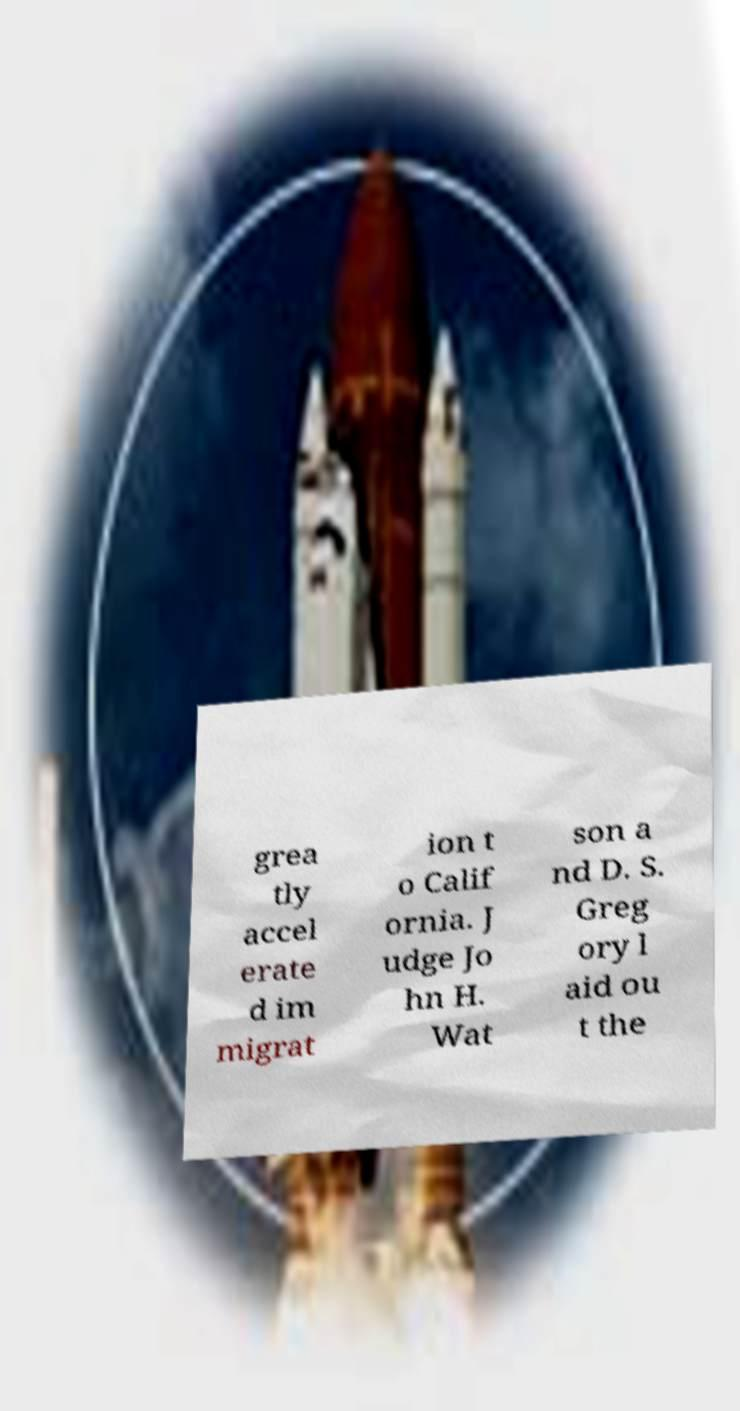There's text embedded in this image that I need extracted. Can you transcribe it verbatim? grea tly accel erate d im migrat ion t o Calif ornia. J udge Jo hn H. Wat son a nd D. S. Greg ory l aid ou t the 